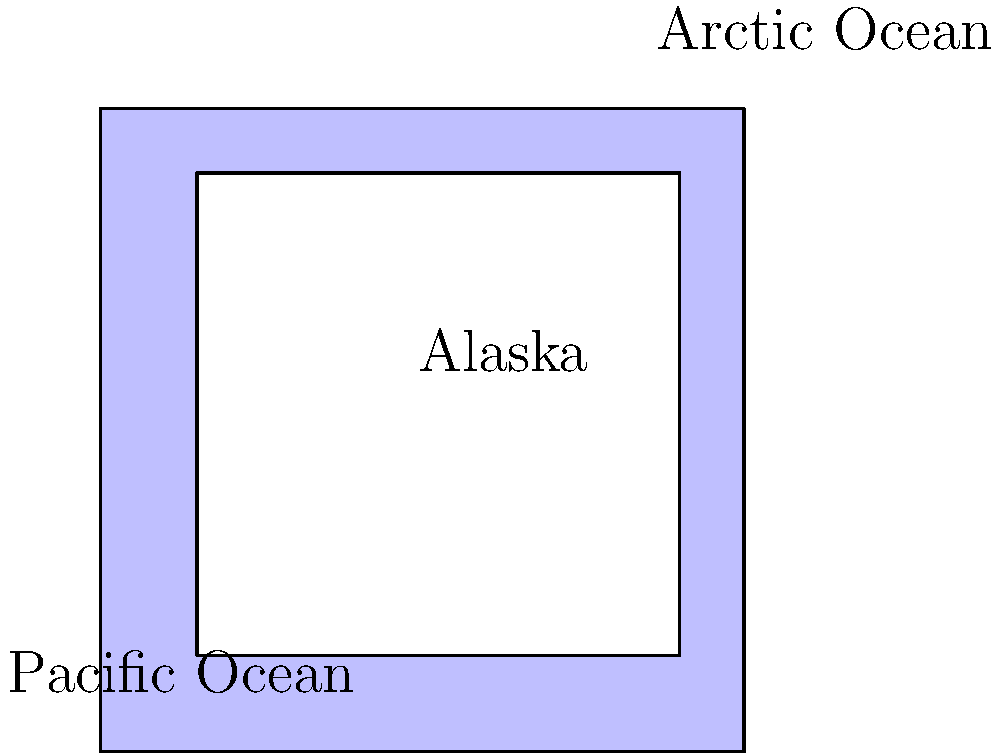In this simplified topological representation of Alaska's coastline as a donut shape, how many holes does the landmass have? To determine the number of holes in this topological representation of Alaska's coastline, we need to follow these steps:

1. Observe the shape: The diagram shows Alaska as a blue region with a white area in the center.

2. Understand topological equivalence: In topology, shapes are considered equivalent if they can be continuously deformed into one another without cutting or gluing.

3. Identify the topology: This representation of Alaska is topologically equivalent to a donut (or torus) shape.

4. Count the holes: A donut shape has one central hole that goes through it.

5. Consider the coastlines: The outer edge represents the Pacific Ocean coastline, while the inner edge represents the Arctic Ocean coastline. These two distinct coastlines create one continuous hole through the landmass.

6. Final assessment: The simplified topological representation of Alaska's coastline has one hole.

This representation highlights an interesting fact about Alaska's geography: it's the only state with coastlines on two different oceans, which creates this unique topological feature.
Answer: 1 